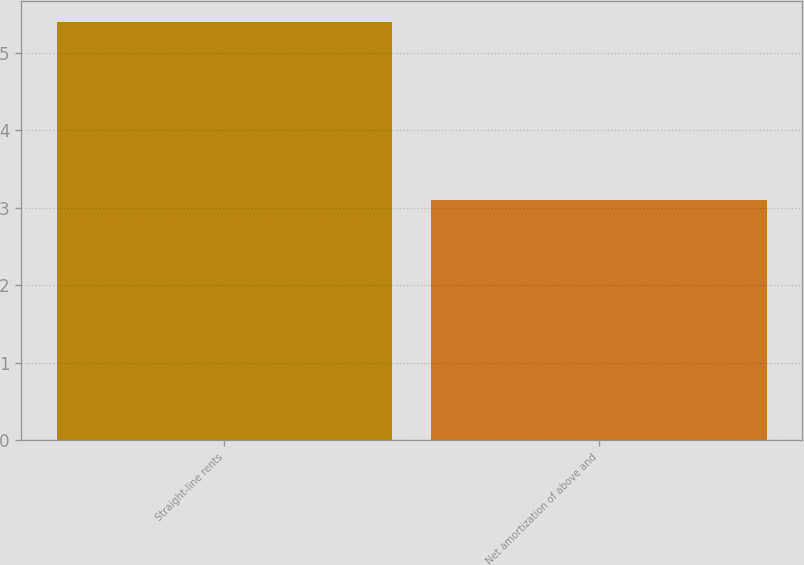<chart> <loc_0><loc_0><loc_500><loc_500><bar_chart><fcel>Straight-line rents<fcel>Net amortization of above and<nl><fcel>5.4<fcel>3.1<nl></chart> 